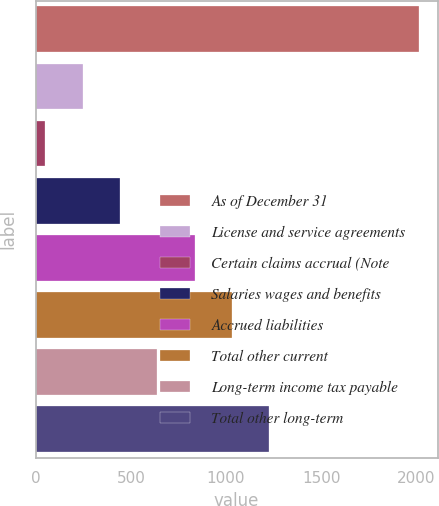Convert chart. <chart><loc_0><loc_0><loc_500><loc_500><bar_chart><fcel>As of December 31<fcel>License and service agreements<fcel>Certain claims accrual (Note<fcel>Salaries wages and benefits<fcel>Accrued liabilities<fcel>Total other current<fcel>Long-term income tax payable<fcel>Total other long-term<nl><fcel>2012<fcel>246.2<fcel>50<fcel>442.4<fcel>834.8<fcel>1031<fcel>638.6<fcel>1227.2<nl></chart> 